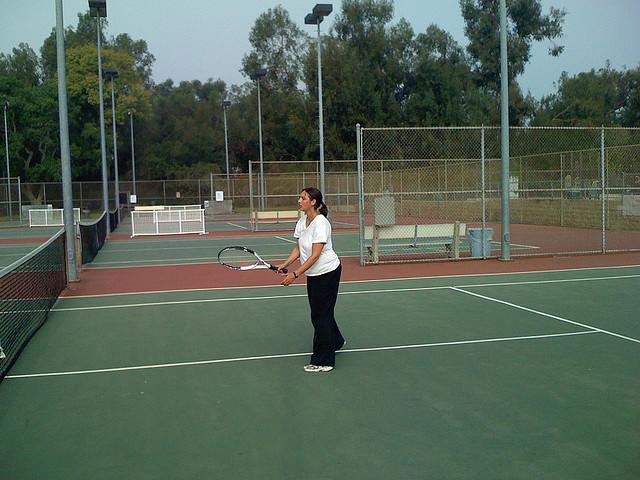How many train cars are visible in the photo?
Give a very brief answer. 0. 